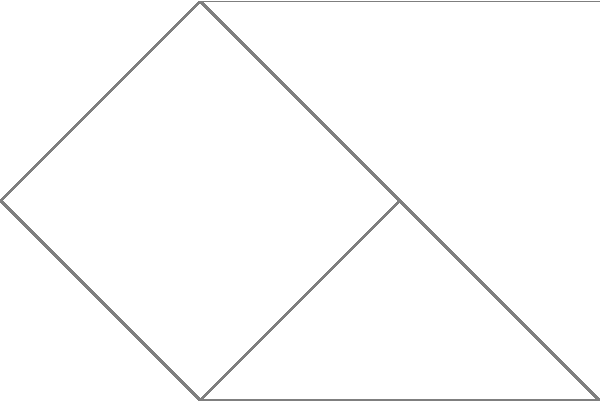In a home wiring diagram, vertices represent electrical outlets and edges represent wires connecting them. The numbers on the edges indicate the cost (in dollars) of installing each wire. What is the minimum cost to connect all outlets while ensuring every outlet is accessible from any other outlet? To find the minimum cost of connecting all outlets while ensuring accessibility, we need to find the Minimum Spanning Tree (MST) of the graph. We can use Kruskal's algorithm to solve this problem:

1. Sort all edges by weight (cost) in ascending order:
   $(v_1, v_4)$: 1
   $(v_1, v_2)$, $(v_3, v_4)$, $(v_4, v_6)$: 2
   $(v_2, v_3)$, $(v_3, v_6)$: 3
   $(v_2, v_5)$: 4

2. Start with an empty set of edges and add edges in order, skipping those that would create a cycle:
   - Add $(v_1, v_4)$: cost = 1
   - Add $(v_1, v_2)$: cost = 1 + 2 = 3
   - Add $(v_3, v_4)$: cost = 3 + 2 = 5
   - Add $(v_4, v_6)$: cost = 5 + 2 = 7
   - Add $(v_2, v_3)$: creates a cycle, skip
   - Add $(v_3, v_6)$: creates a cycle, skip
   - Add $(v_2, v_5)$: cost = 7 + 4 = 11

3. The MST includes edges: $(v_1, v_4)$, $(v_1, v_2)$, $(v_3, v_4)$, $(v_4, v_6)$, and $(v_2, v_5)$.

The total minimum cost is $11.
Answer: $11 